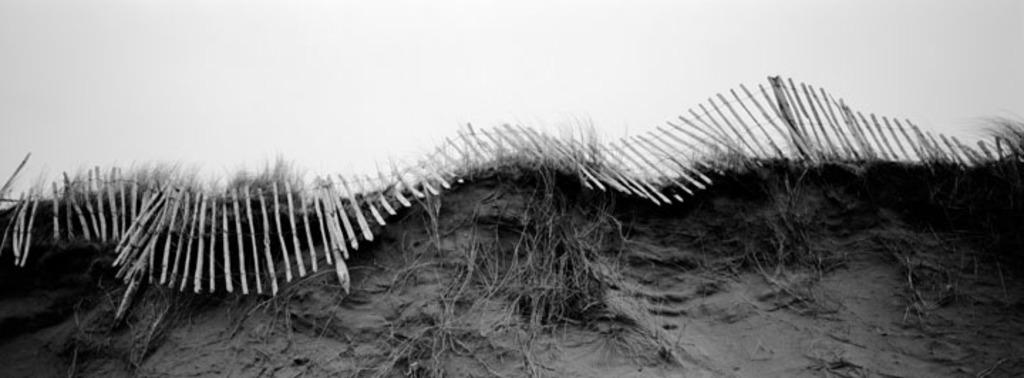What is the color scheme of the image? The image is black and white. What can be seen in the foreground of the image? There is a fence in the image. What is visible in the background of the image? The sky is visible in the background of the image. What type of straw is being used to shock the class in the image? There is no straw or shocking of a class present in the image; it is a black and white image with a fence and visible sky. 